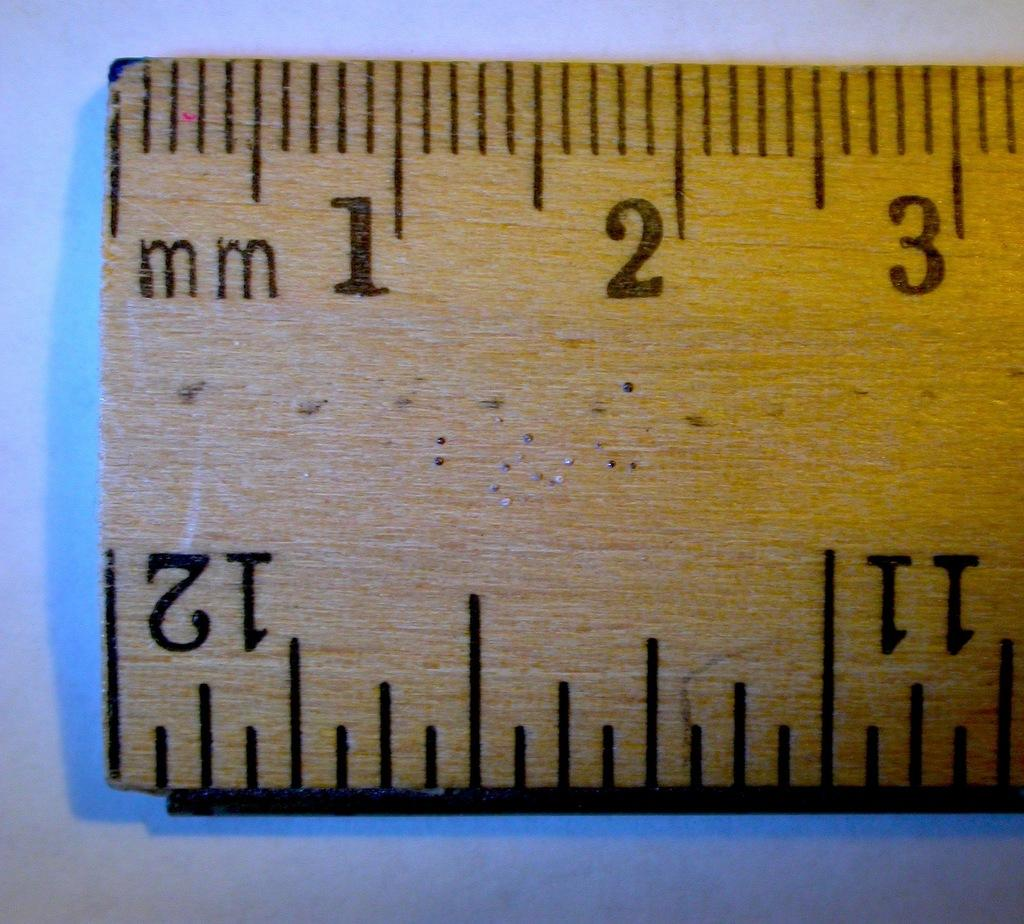Provide a one-sentence caption for the provided image. The ruler shows up to three full millimeters and a twelve. 